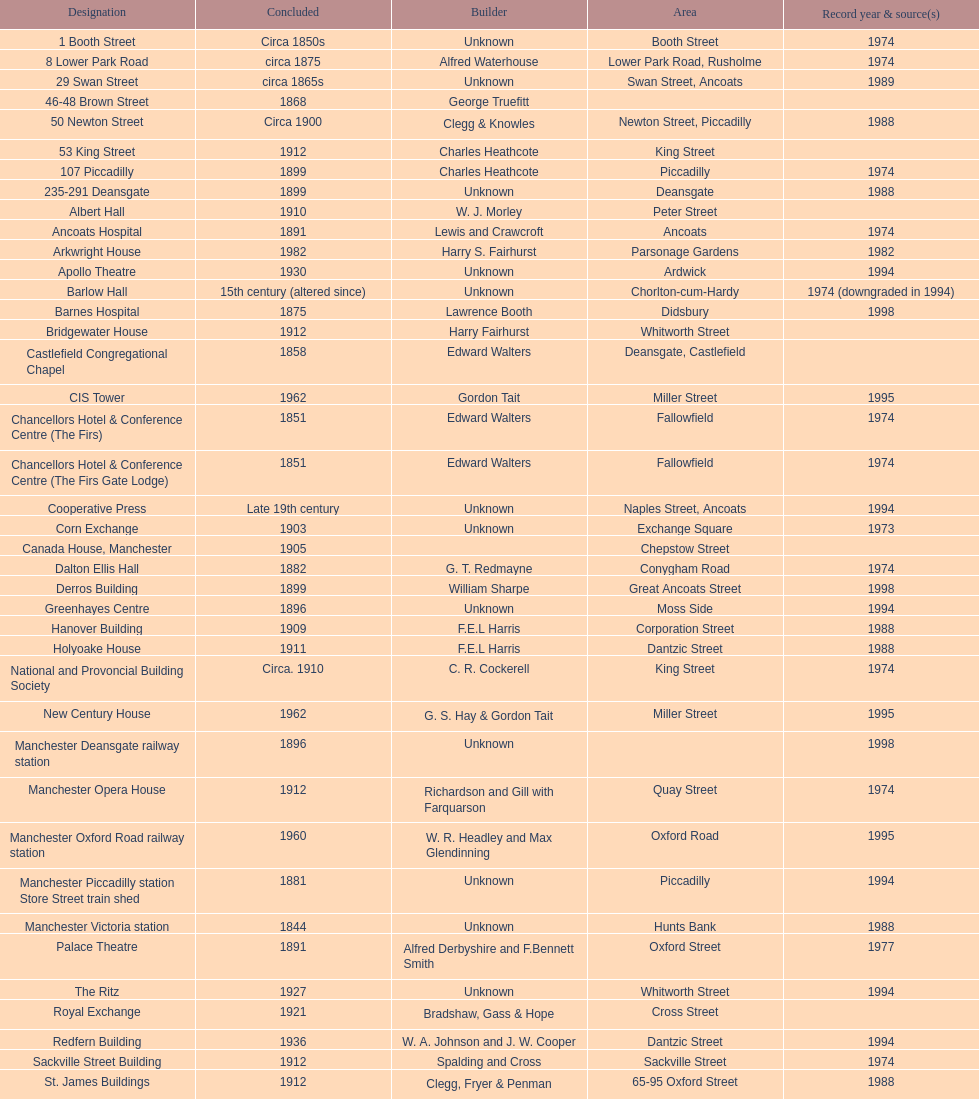Which year has the most buildings listed? 1974. 